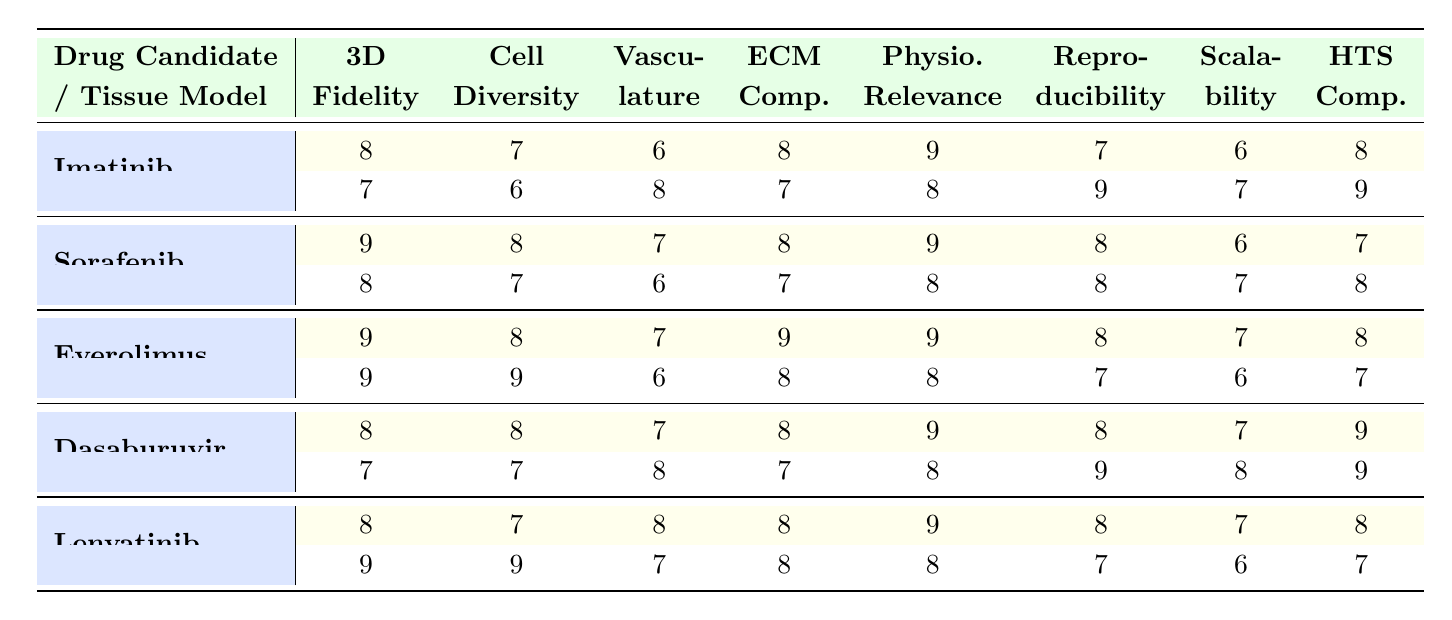What is the evaluation score for Imatinib in the Liver organoid model for physiological relevance? The table indicates that the score for physiological relevance under the Liver organoid model for Imatinib is 9.
Answer: 9 Which drug candidate has the highest score for 3D structure fidelity in the Kidney-on-a-chip model? By examining the scores, Sorafenib has the highest score of 9 for 3D structure fidelity in the Kidney-on-a-chip model, compared to Imatinib, Dasaburuvir, and Lenvatinib, which have lower scores.
Answer: Sorafenib What is the average cell type diversity score for Everolimus across its tissue models? The cell type diversity scores for Everolimus are 8 and 9 for the Liver organoid and Brain organoid respectively. The average is (8 + 9) / 2 = 8.5.
Answer: 8.5 Is the extracellular matrix composition score for Lenvatinib in the 3D cardiac tissue model greater than its score in the Brain organoid model? In the table, the score for extracellular matrix composition for Lenvatinib is 8 in the 3D cardiac tissue model and 8 in the Brain organoid model. Thus, they are equal, so the answer is no.
Answer: No Which drug has the lowest score for vasculature presence across all tissue models? By comparing the vasculature presence scores across all tissue models, Dasaburuvir has the lowest score of 6 in the Lung alveolar model.
Answer: Dasaburuvir 